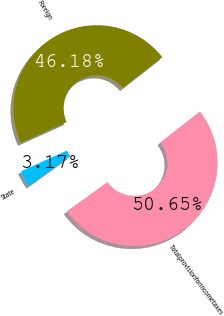Convert chart. <chart><loc_0><loc_0><loc_500><loc_500><pie_chart><fcel>State<fcel>Foreign<fcel>Totalprovisionforincometaxes<nl><fcel>3.17%<fcel>46.18%<fcel>50.64%<nl></chart> 